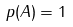<formula> <loc_0><loc_0><loc_500><loc_500>p ( A ) = 1</formula> 